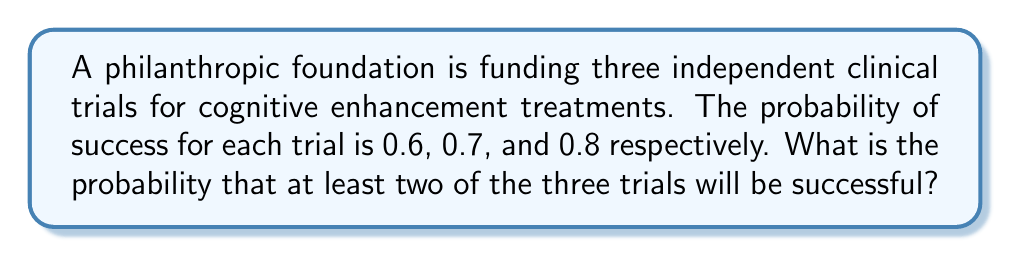Teach me how to tackle this problem. Let's approach this step-by-step using the complement method:

1) First, let's define our events:
   $A$: Trial 1 succeeds (P(A) = 0.6)
   $B$: Trial 2 succeeds (P(B) = 0.7)
   $C$: Trial 3 succeeds (P(C) = 0.8)

2) We want P(at least two trials succeed). It's easier to calculate P(fewer than two succeed) and subtract from 1.

3) P(fewer than two succeed) = P(no trials succeed) + P(exactly one trial succeeds)

4) P(no trials succeed) = P(A' ∩ B' ∩ C')
   $$ P(A' \cap B' \cap C') = (1-0.6)(1-0.7)(1-0.8) = 0.4 \times 0.3 \times 0.2 = 0.024 $$

5) P(exactly one trial succeeds) = P(A ∩ B' ∩ C') + P(A' ∩ B ∩ C') + P(A' ∩ B' ∩ C)
   $$ P(A \cap B' \cap C') = 0.6 \times 0.3 \times 0.2 = 0.036 $$
   $$ P(A' \cap B \cap C') = 0.4 \times 0.7 \times 0.2 = 0.056 $$
   $$ P(A' \cap B' \cap C) = 0.4 \times 0.3 \times 0.8 = 0.096 $$
   Sum: 0.036 + 0.056 + 0.096 = 0.188

6) P(fewer than two succeed) = 0.024 + 0.188 = 0.212

7) Therefore, P(at least two succeed) = 1 - P(fewer than two succeed)
   $$ 1 - 0.212 = 0.788 $$
Answer: 0.788 